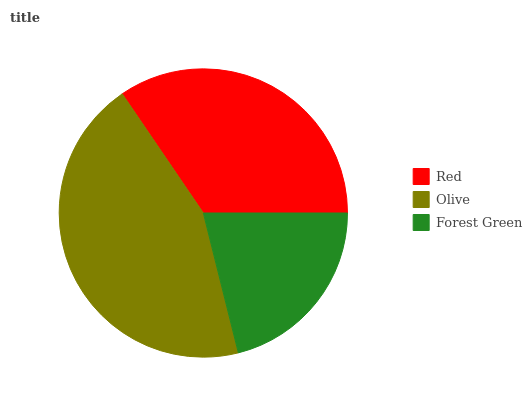Is Forest Green the minimum?
Answer yes or no. Yes. Is Olive the maximum?
Answer yes or no. Yes. Is Olive the minimum?
Answer yes or no. No. Is Forest Green the maximum?
Answer yes or no. No. Is Olive greater than Forest Green?
Answer yes or no. Yes. Is Forest Green less than Olive?
Answer yes or no. Yes. Is Forest Green greater than Olive?
Answer yes or no. No. Is Olive less than Forest Green?
Answer yes or no. No. Is Red the high median?
Answer yes or no. Yes. Is Red the low median?
Answer yes or no. Yes. Is Forest Green the high median?
Answer yes or no. No. Is Forest Green the low median?
Answer yes or no. No. 